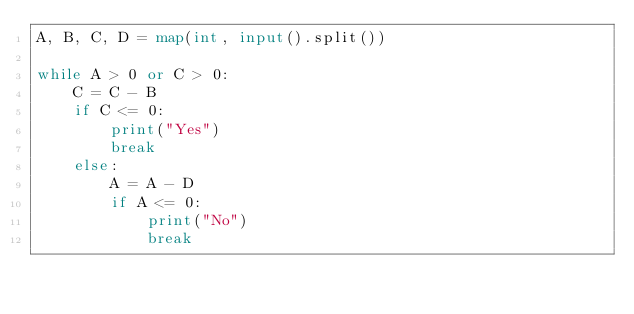<code> <loc_0><loc_0><loc_500><loc_500><_Python_>A, B, C, D = map(int, input().split())

while A > 0 or C > 0:
    C = C - B
    if C <= 0:
        print("Yes")
        break
    else:
        A = A - D
        if A <= 0:
            print("No")
            break
</code> 